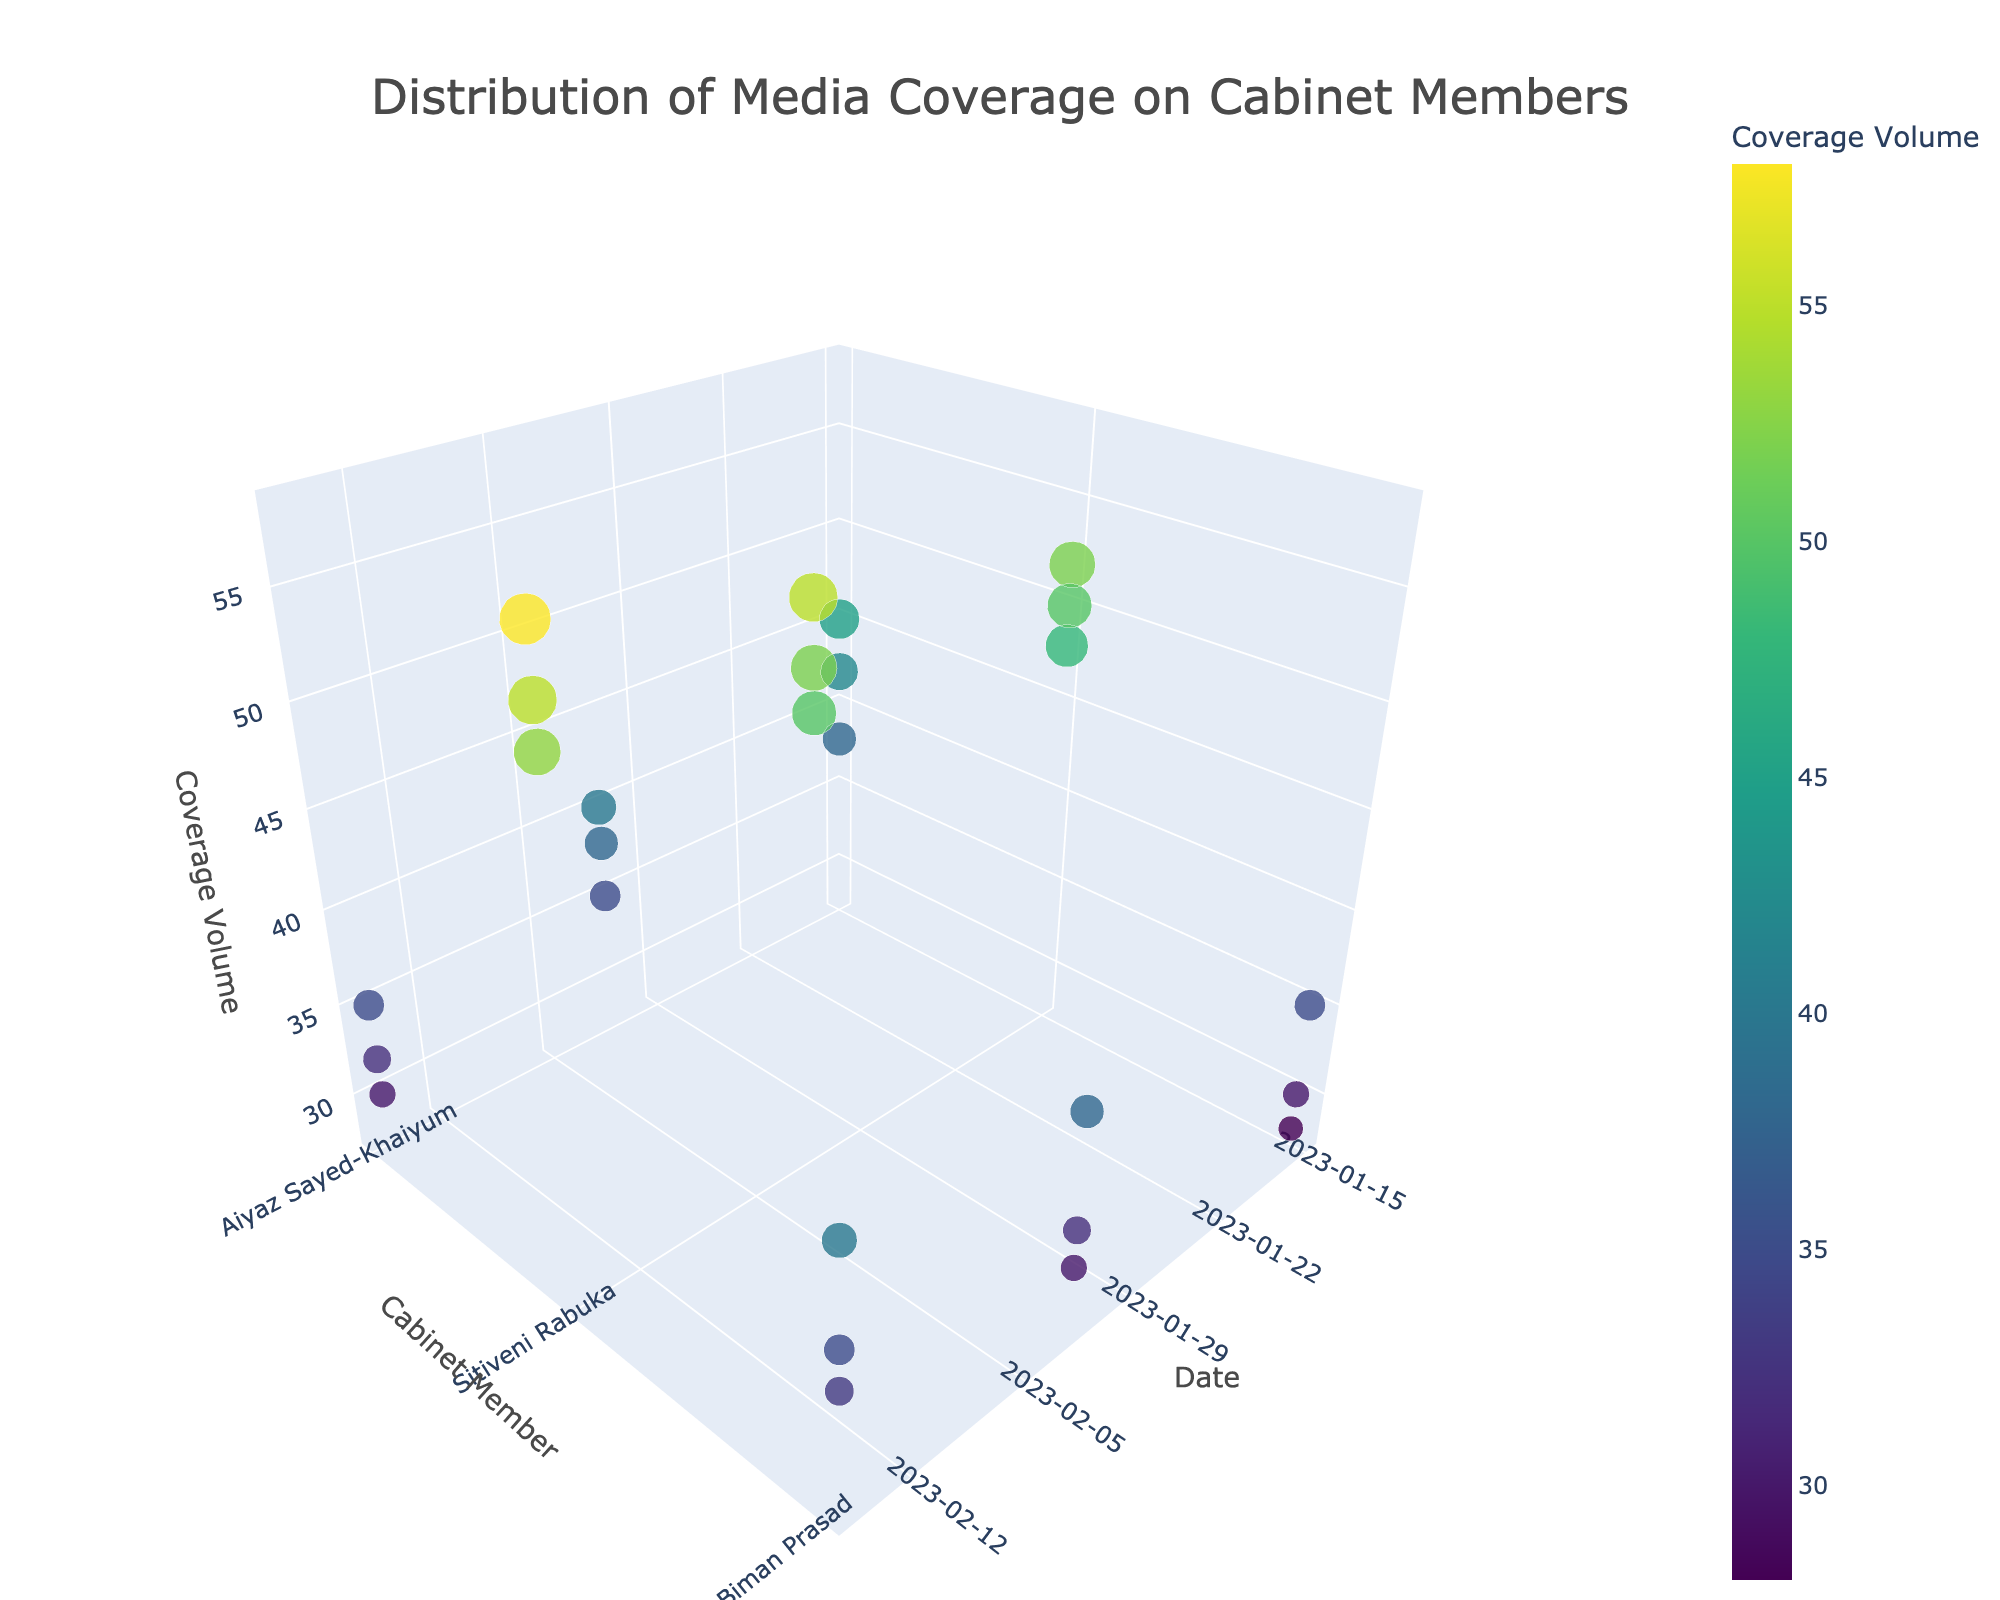What is the title of the 3D volume plot? The title of the plot is located at the top and it is intended to provide an overview of what the figure represents. The title reads "Distribution of Media Coverage on Cabinet Members".
Answer: Distribution of Media Coverage on Cabinet Members How does the coverage of Sitiveni Rabuka change from January 15, 2023, to February 15, 2023? Looking at the z-axis values for Sitiveni Rabuka on January 15, 2023 (52, 48, 50) and February 15, 2023 (58, 53, 55), you can observe an increase in the coverage volume for each news outlet. Calculate the difference for each news outlet: 
(58-52)=6, (53-48)=5, (55-50)=5. The coverage volume has increased.
Answer: Increases Which cabinet member had the highest coverage volume on February 15, 2023? On February 15, 2023, by checking the z-axis values where the y-axis (Cabinet Member) is Sitiveni Rabuka, Aiyaz Sayed-Khaiyum, and Biman Prasad, we find the highest values to belong to Sitiveni Rabuka with volumes 58, 53, 55 respectively.
Answer: Sitiveni Rabuka Do any of the cabinet members have decreasing coverage over time? Examine the trend of coverage volumes for each cabinet member across the dates. For Aiyaz Sayed-Khaiyum, the values (45, 40, 35) show a decrease. Therefore, Aiyaz Sayed-Khaiyum's coverage decreases over time.
Answer: Yes, Aiyaz Sayed-Khaiyum Which news outlet covered Aiyaz Sayed-Khaiyum the least on January 15, 2023? On January 15, 2023, check the z-axis values for Aiyaz Sayed-Khaiyum at each news outlet. Fiji Sun (45), Fiji Times (38), and FBC News (42); Fiji Times has the lowest value.
Answer: Fiji Times How many data points are shown in the plot? Count all the data points in the plot, each marker represents a data point. With 3 cabinet members covered by 3 news outlets on 3 different dates, there are 27 data points.
Answer: 27 Compare the coverage volumes of Sitiveni Rabuka across all outlets on February 1, 2023. Which outlet had the highest coverage? For February 1, 2023, check the z-axis values for Sitiveni Rabuka across the news outlets. Fiji Sun (55), Fiji Times (50), FBC News (52). The highest value is for Fiji Sun.
Answer: Fiji Sun What's the average coverage volume for Biman Prasad on February 1, 2023? On February 1, 2023, the z-axis values for Biman Prasad are 32, 38, and 30. Sum these values (32 + 38 + 30 = 100) and divide by 3 to find the average coverage volume. 100/3 = 33.33
Answer: 33.33 